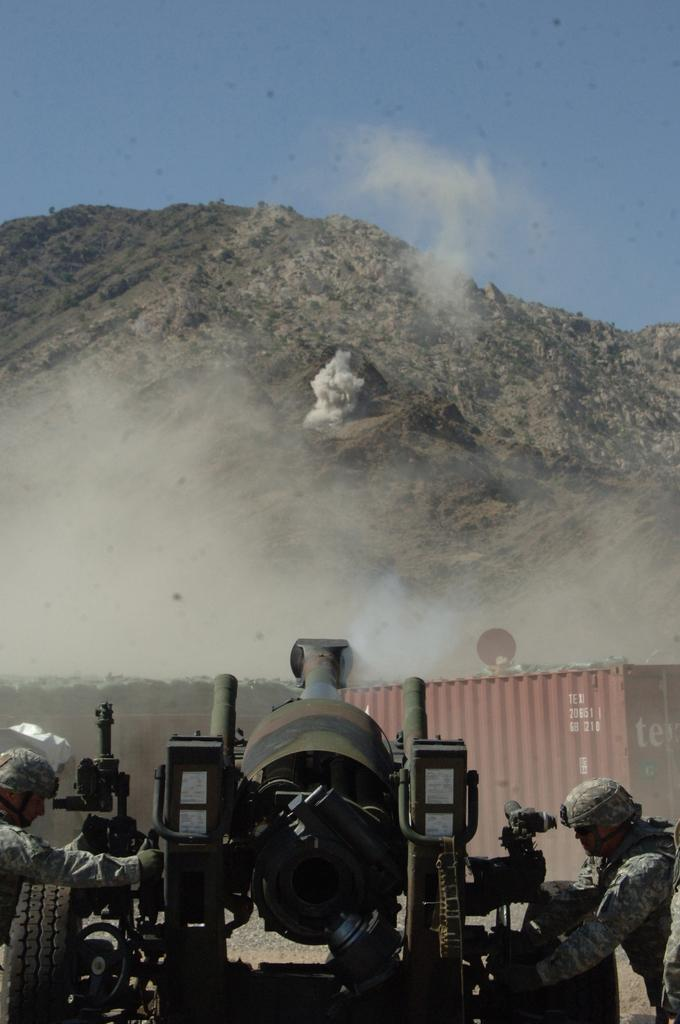How many people are present in the image? There are two persons in the image. What is the large vehicle in the image? There is a tanker in the image. What type of natural landform can be seen in the image? There is a mountain visible in the image. What is visible above the landforms and vehicles in the image? The sky is visible in the image. What type of muscle can be seen flexing in the image? There is no muscle visible in the image; it features two people, a tanker, a mountain, and the sky. Can you tell me how many drawers are present in the image? There are no drawers present in the image. 